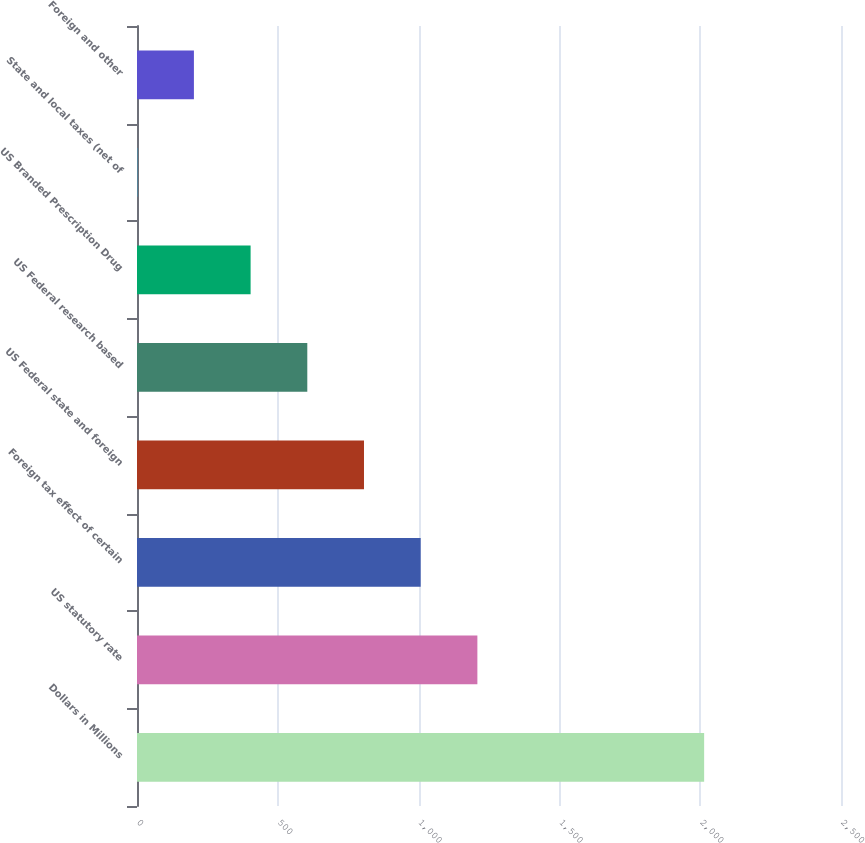<chart> <loc_0><loc_0><loc_500><loc_500><bar_chart><fcel>Dollars in Millions<fcel>US statutory rate<fcel>Foreign tax effect of certain<fcel>US Federal state and foreign<fcel>US Federal research based<fcel>US Branded Prescription Drug<fcel>State and local taxes (net of<fcel>Foreign and other<nl><fcel>2014<fcel>1208.72<fcel>1007.4<fcel>806.08<fcel>604.76<fcel>403.44<fcel>0.8<fcel>202.12<nl></chart> 